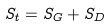Convert formula to latex. <formula><loc_0><loc_0><loc_500><loc_500>S _ { t } = S _ { G } + S _ { D }</formula> 